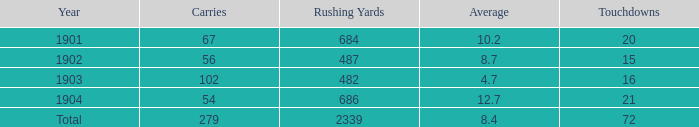What is the most number of touchdowns that have fewer than 105 points, averages over 4.7, and fewer than 487 rushing yards? None. 